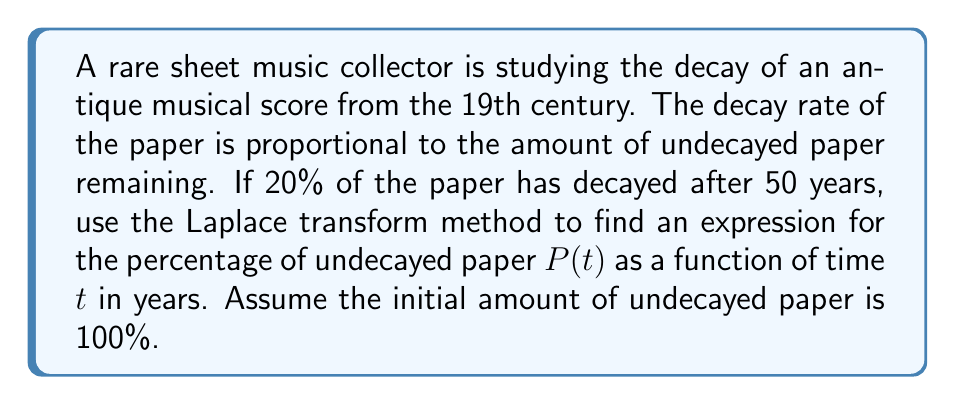Can you answer this question? Let's approach this problem step-by-step using the Laplace transform method:

1) First, we need to set up our differential equation. Let $P(t)$ be the percentage of undecayed paper at time $t$. The decay rate is proportional to the amount of undecayed paper, so we have:

   $$\frac{dP}{dt} = -kP$$

   where $k$ is the decay constant.

2) We know that initially, 100% of the paper is undecayed, so $P(0) = 100$.

3) Let's apply the Laplace transform to both sides of the equation:

   $$\mathcal{L}\left\{\frac{dP}{dt}\right\} = \mathcal{L}\{-kP\}$$

4) Using the Laplace transform properties:

   $$s\mathcal{L}\{P\} - P(0) = -k\mathcal{L}\{P\}$$

5) Let $\mathcal{L}\{P\} = \bar{P}(s)$. Substituting and rearranging:

   $$s\bar{P}(s) - 100 = -k\bar{P}(s)$$
   $$(s+k)\bar{P}(s) = 100$$
   $$\bar{P}(s) = \frac{100}{s+k}$$

6) The inverse Laplace transform of this is:

   $$P(t) = 100e^{-kt}$$

7) Now, we need to find $k$. We know that after 50 years, 80% of the paper remains undecayed. So:

   $$80 = 100e^{-k(50)}$$
   $$\ln(0.8) = -50k$$
   $$k = -\frac{\ln(0.8)}{50} \approx 0.00446$$

8) Therefore, our final expression for $P(t)$ is:

   $$P(t) = 100e^{-0.00446t}$$
Answer: $$P(t) = 100e^{-0.00446t}$$ 